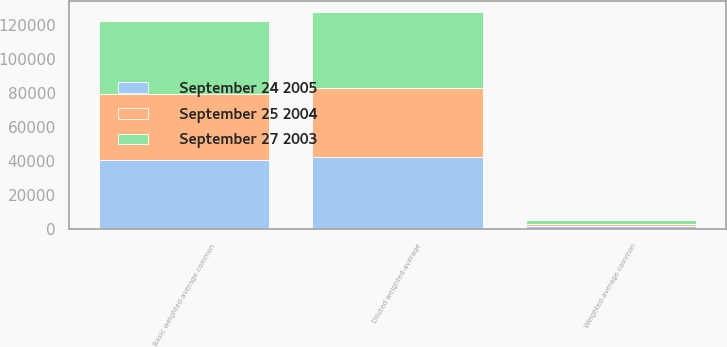Convert chart. <chart><loc_0><loc_0><loc_500><loc_500><stacked_bar_chart><ecel><fcel>Basic weighted-average common<fcel>Weighted-average common<fcel>Diluted weighted-average<nl><fcel>September 27 2003<fcel>42824<fcel>2302<fcel>45126<nl><fcel>September 24 2005<fcel>40516<fcel>2077<fcel>42593<nl><fcel>September 25 2004<fcel>39258<fcel>1003<fcel>40261<nl></chart> 